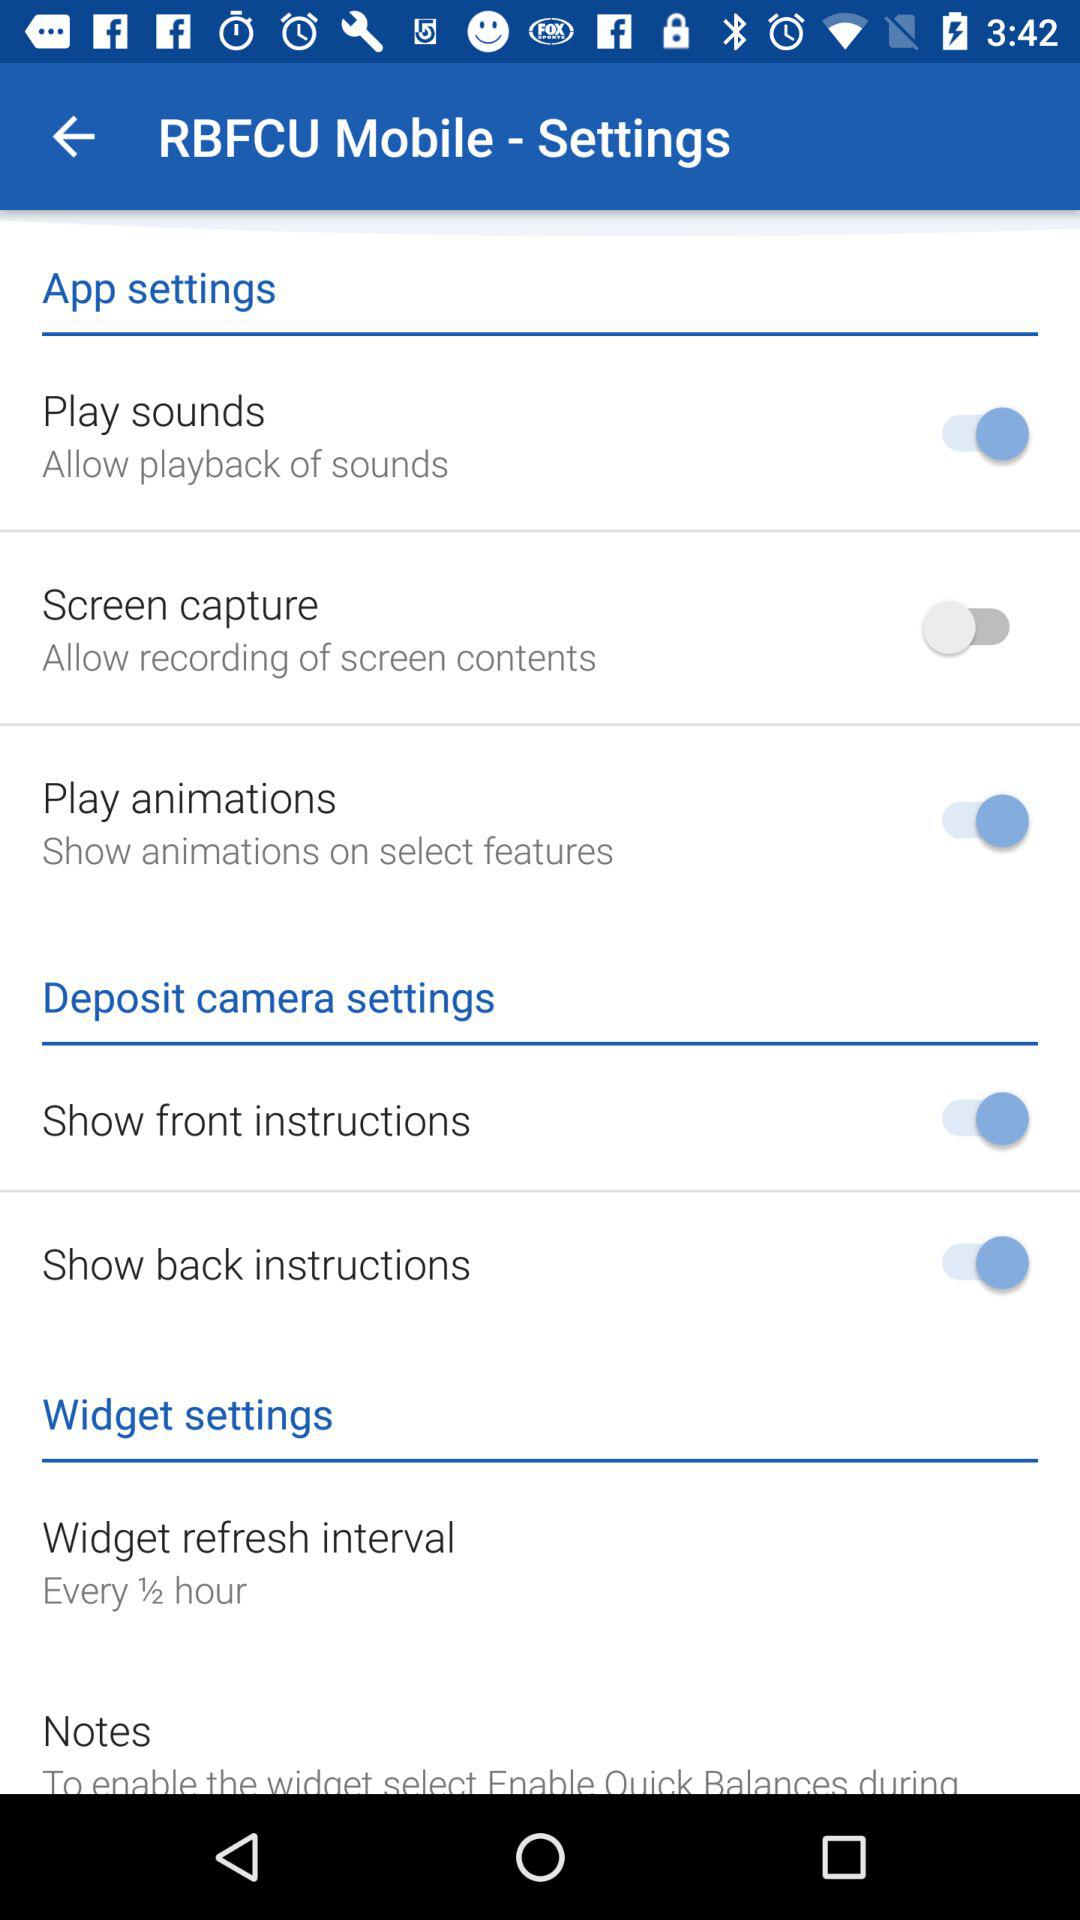What is the status of the "Screen capture"? The status is "off". 